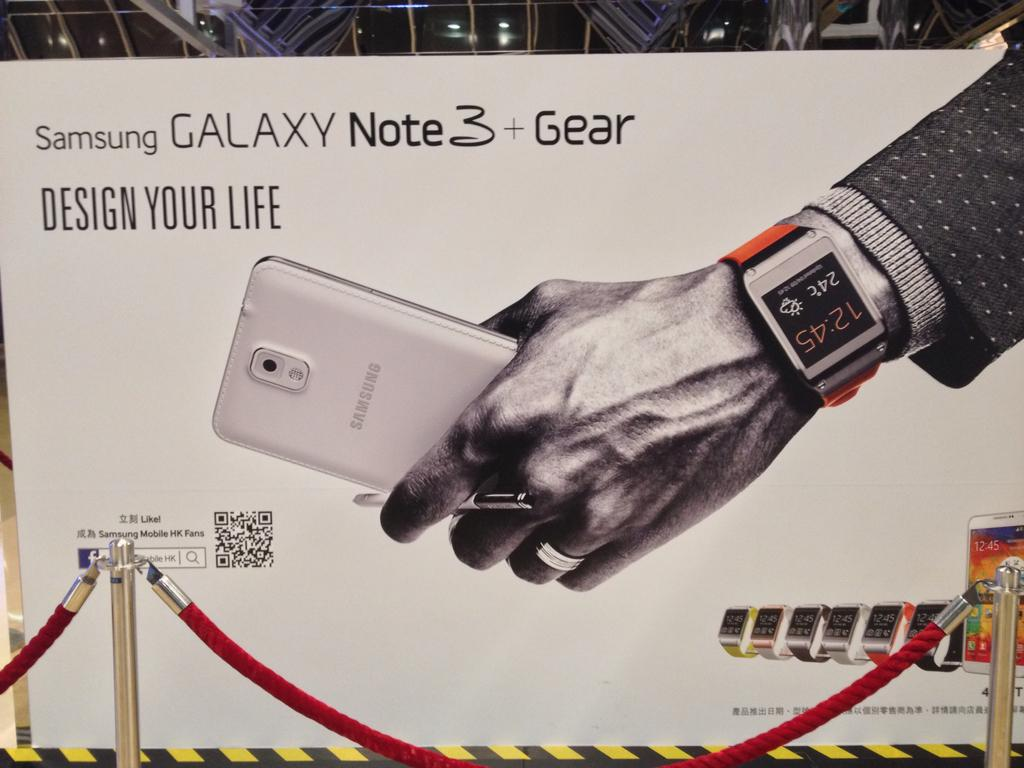<image>
Render a clear and concise summary of the photo. An ad for the Samsung Galaxy Note 3 shows a man's hand holding the phone. 